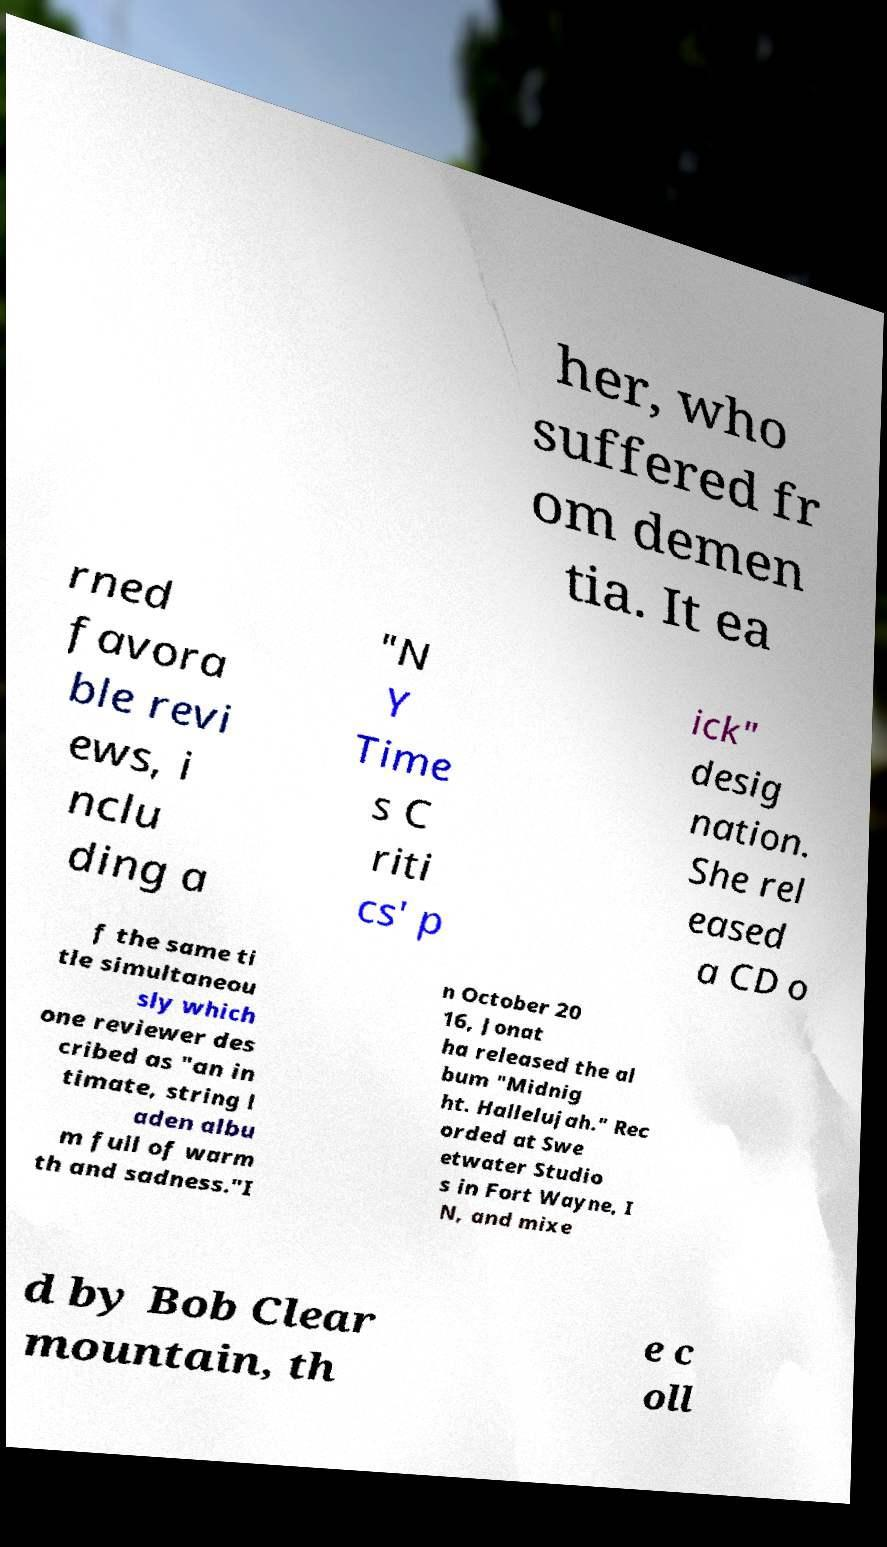Can you accurately transcribe the text from the provided image for me? her, who suffered fr om demen tia. It ea rned favora ble revi ews, i nclu ding a "N Y Time s C riti cs' p ick" desig nation. She rel eased a CD o f the same ti tle simultaneou sly which one reviewer des cribed as "an in timate, string l aden albu m full of warm th and sadness."I n October 20 16, Jonat ha released the al bum "Midnig ht. Hallelujah." Rec orded at Swe etwater Studio s in Fort Wayne, I N, and mixe d by Bob Clear mountain, th e c oll 